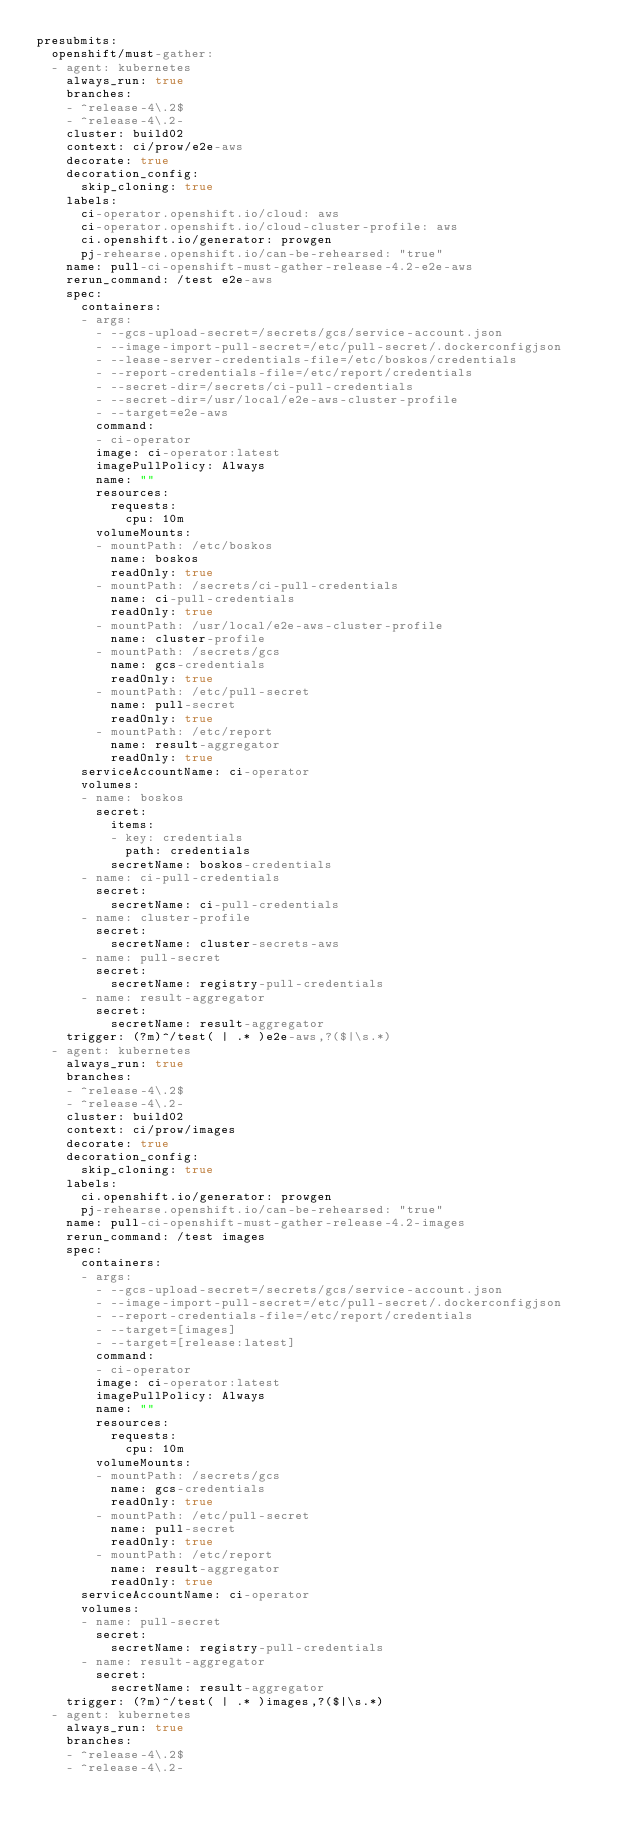<code> <loc_0><loc_0><loc_500><loc_500><_YAML_>presubmits:
  openshift/must-gather:
  - agent: kubernetes
    always_run: true
    branches:
    - ^release-4\.2$
    - ^release-4\.2-
    cluster: build02
    context: ci/prow/e2e-aws
    decorate: true
    decoration_config:
      skip_cloning: true
    labels:
      ci-operator.openshift.io/cloud: aws
      ci-operator.openshift.io/cloud-cluster-profile: aws
      ci.openshift.io/generator: prowgen
      pj-rehearse.openshift.io/can-be-rehearsed: "true"
    name: pull-ci-openshift-must-gather-release-4.2-e2e-aws
    rerun_command: /test e2e-aws
    spec:
      containers:
      - args:
        - --gcs-upload-secret=/secrets/gcs/service-account.json
        - --image-import-pull-secret=/etc/pull-secret/.dockerconfigjson
        - --lease-server-credentials-file=/etc/boskos/credentials
        - --report-credentials-file=/etc/report/credentials
        - --secret-dir=/secrets/ci-pull-credentials
        - --secret-dir=/usr/local/e2e-aws-cluster-profile
        - --target=e2e-aws
        command:
        - ci-operator
        image: ci-operator:latest
        imagePullPolicy: Always
        name: ""
        resources:
          requests:
            cpu: 10m
        volumeMounts:
        - mountPath: /etc/boskos
          name: boskos
          readOnly: true
        - mountPath: /secrets/ci-pull-credentials
          name: ci-pull-credentials
          readOnly: true
        - mountPath: /usr/local/e2e-aws-cluster-profile
          name: cluster-profile
        - mountPath: /secrets/gcs
          name: gcs-credentials
          readOnly: true
        - mountPath: /etc/pull-secret
          name: pull-secret
          readOnly: true
        - mountPath: /etc/report
          name: result-aggregator
          readOnly: true
      serviceAccountName: ci-operator
      volumes:
      - name: boskos
        secret:
          items:
          - key: credentials
            path: credentials
          secretName: boskos-credentials
      - name: ci-pull-credentials
        secret:
          secretName: ci-pull-credentials
      - name: cluster-profile
        secret:
          secretName: cluster-secrets-aws
      - name: pull-secret
        secret:
          secretName: registry-pull-credentials
      - name: result-aggregator
        secret:
          secretName: result-aggregator
    trigger: (?m)^/test( | .* )e2e-aws,?($|\s.*)
  - agent: kubernetes
    always_run: true
    branches:
    - ^release-4\.2$
    - ^release-4\.2-
    cluster: build02
    context: ci/prow/images
    decorate: true
    decoration_config:
      skip_cloning: true
    labels:
      ci.openshift.io/generator: prowgen
      pj-rehearse.openshift.io/can-be-rehearsed: "true"
    name: pull-ci-openshift-must-gather-release-4.2-images
    rerun_command: /test images
    spec:
      containers:
      - args:
        - --gcs-upload-secret=/secrets/gcs/service-account.json
        - --image-import-pull-secret=/etc/pull-secret/.dockerconfigjson
        - --report-credentials-file=/etc/report/credentials
        - --target=[images]
        - --target=[release:latest]
        command:
        - ci-operator
        image: ci-operator:latest
        imagePullPolicy: Always
        name: ""
        resources:
          requests:
            cpu: 10m
        volumeMounts:
        - mountPath: /secrets/gcs
          name: gcs-credentials
          readOnly: true
        - mountPath: /etc/pull-secret
          name: pull-secret
          readOnly: true
        - mountPath: /etc/report
          name: result-aggregator
          readOnly: true
      serviceAccountName: ci-operator
      volumes:
      - name: pull-secret
        secret:
          secretName: registry-pull-credentials
      - name: result-aggregator
        secret:
          secretName: result-aggregator
    trigger: (?m)^/test( | .* )images,?($|\s.*)
  - agent: kubernetes
    always_run: true
    branches:
    - ^release-4\.2$
    - ^release-4\.2-</code> 